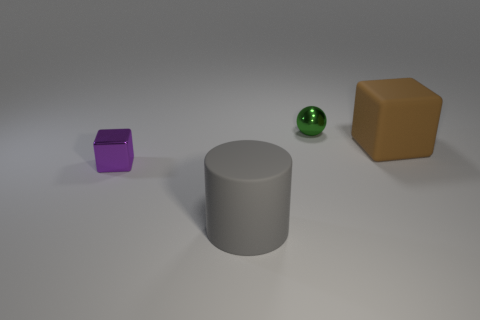There is a rubber object behind the rubber object that is to the left of the small thing that is behind the purple shiny cube; what size is it?
Ensure brevity in your answer.  Large. There is a shiny thing behind the brown thing; how big is it?
Offer a terse response. Small. What is the shape of the object that is the same material as the brown block?
Make the answer very short. Cylinder. Does the block that is in front of the brown matte cube have the same material as the tiny green object?
Offer a very short reply. Yes. How many things are large rubber things behind the metal cube or large things that are right of the gray cylinder?
Provide a short and direct response. 1. There is a big matte thing in front of the brown block; is it the same shape as the metallic thing that is on the right side of the large matte cylinder?
Offer a terse response. No. There is a green metal object that is the same size as the purple shiny object; what shape is it?
Make the answer very short. Sphere. What number of metal things are either big yellow objects or brown things?
Your response must be concise. 0. Does the small sphere behind the large cylinder have the same material as the large object behind the tiny cube?
Make the answer very short. No. What is the color of the block that is the same material as the cylinder?
Give a very brief answer. Brown. 